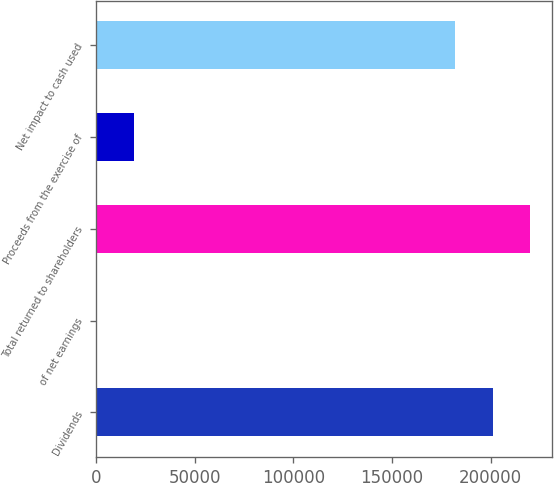<chart> <loc_0><loc_0><loc_500><loc_500><bar_chart><fcel>Dividends<fcel>of net earnings<fcel>Total returned to shareholders<fcel>Proceeds from the exercise of<fcel>Net impact to cash used<nl><fcel>200988<fcel>53.6<fcel>220156<fcel>19222.3<fcel>181819<nl></chart> 